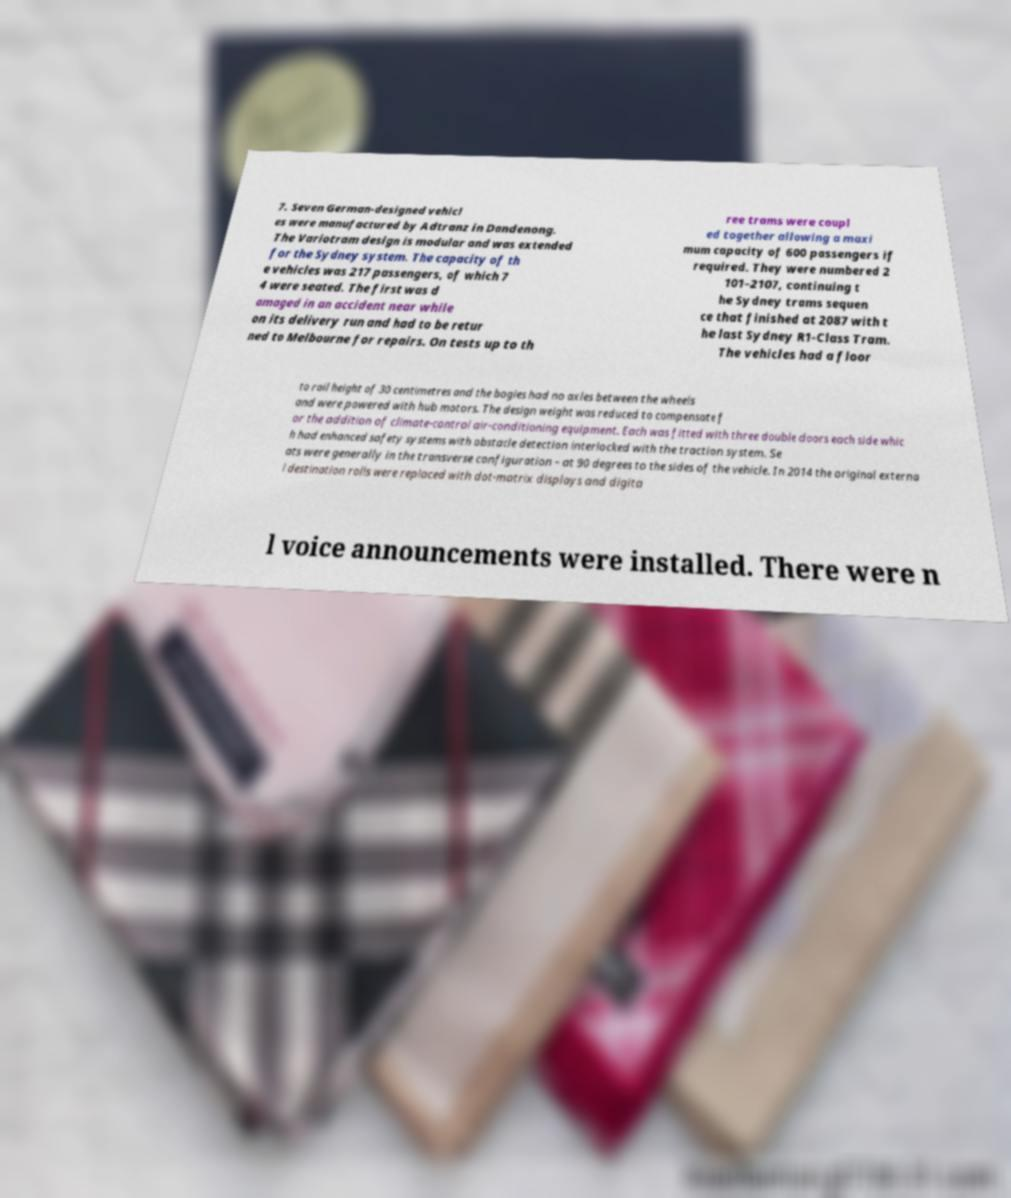Could you assist in decoding the text presented in this image and type it out clearly? 7. Seven German-designed vehicl es were manufactured by Adtranz in Dandenong. The Variotram design is modular and was extended for the Sydney system. The capacity of th e vehicles was 217 passengers, of which 7 4 were seated. The first was d amaged in an accident near while on its delivery run and had to be retur ned to Melbourne for repairs. On tests up to th ree trams were coupl ed together allowing a maxi mum capacity of 600 passengers if required. They were numbered 2 101–2107, continuing t he Sydney trams sequen ce that finished at 2087 with t he last Sydney R1-Class Tram. The vehicles had a floor to rail height of 30 centimetres and the bogies had no axles between the wheels and were powered with hub motors. The design weight was reduced to compensate f or the addition of climate-control air-conditioning equipment. Each was fitted with three double doors each side whic h had enhanced safety systems with obstacle detection interlocked with the traction system. Se ats were generally in the transverse configuration – at 90 degrees to the sides of the vehicle. In 2014 the original externa l destination rolls were replaced with dot-matrix displays and digita l voice announcements were installed. There were n 